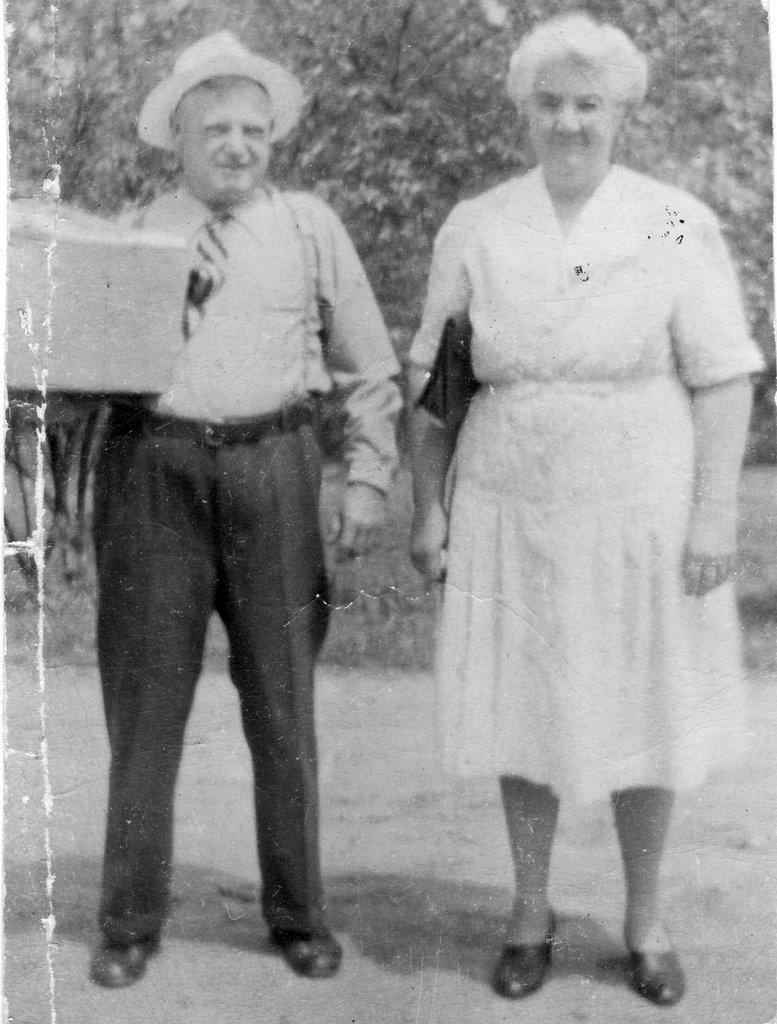Please provide a concise description of this image. In the center of the image we can see a man and a lady standing. In the background there are trees. 